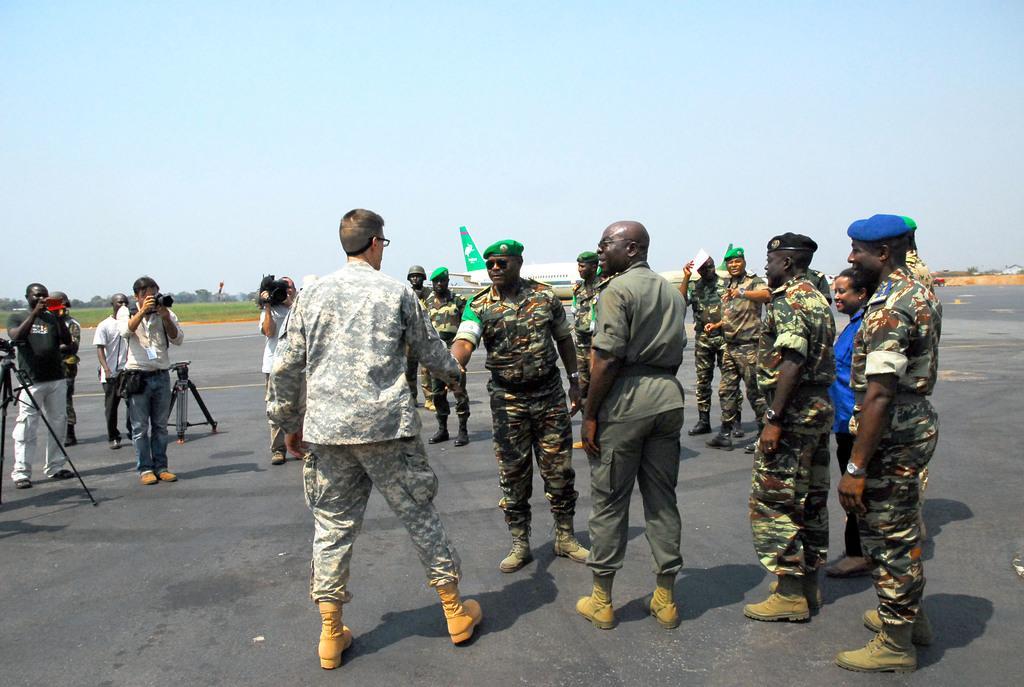Describe this image in one or two sentences. In this image I can see few persons wearing uniforms are standing on the ground and few other persons are standing and holding cameras in their hands. In the background I can see a aeroplane which is white and green in color, some grass, few trees and the sky. 